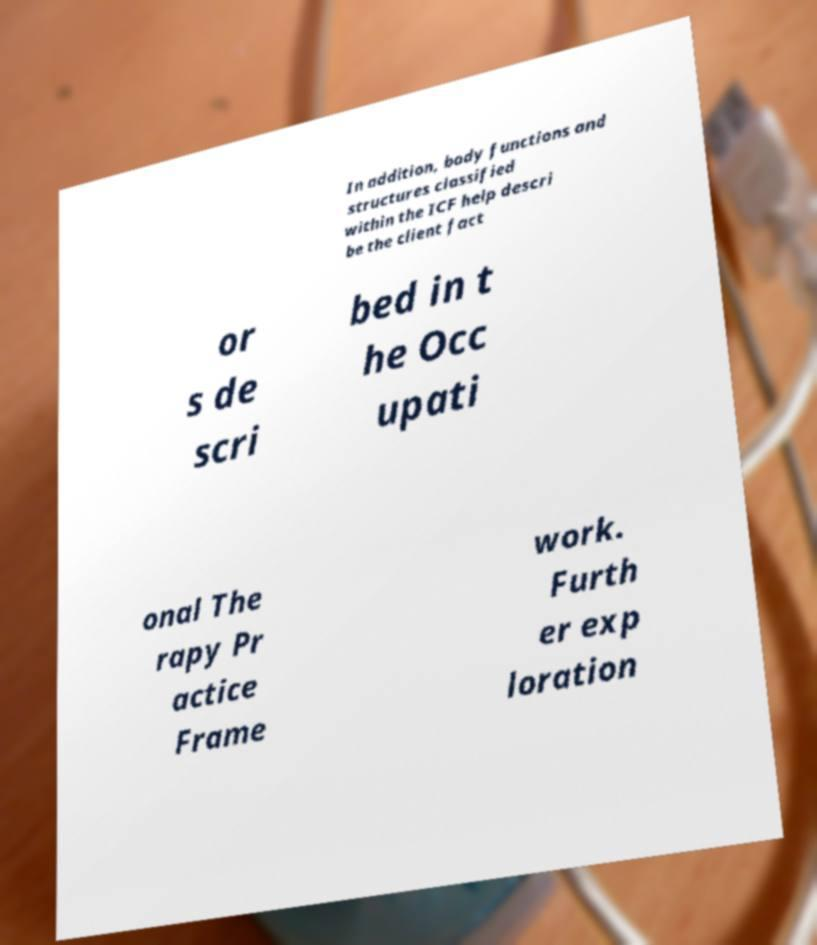Could you extract and type out the text from this image? In addition, body functions and structures classified within the ICF help descri be the client fact or s de scri bed in t he Occ upati onal The rapy Pr actice Frame work. Furth er exp loration 